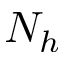<formula> <loc_0><loc_0><loc_500><loc_500>N _ { h }</formula> 